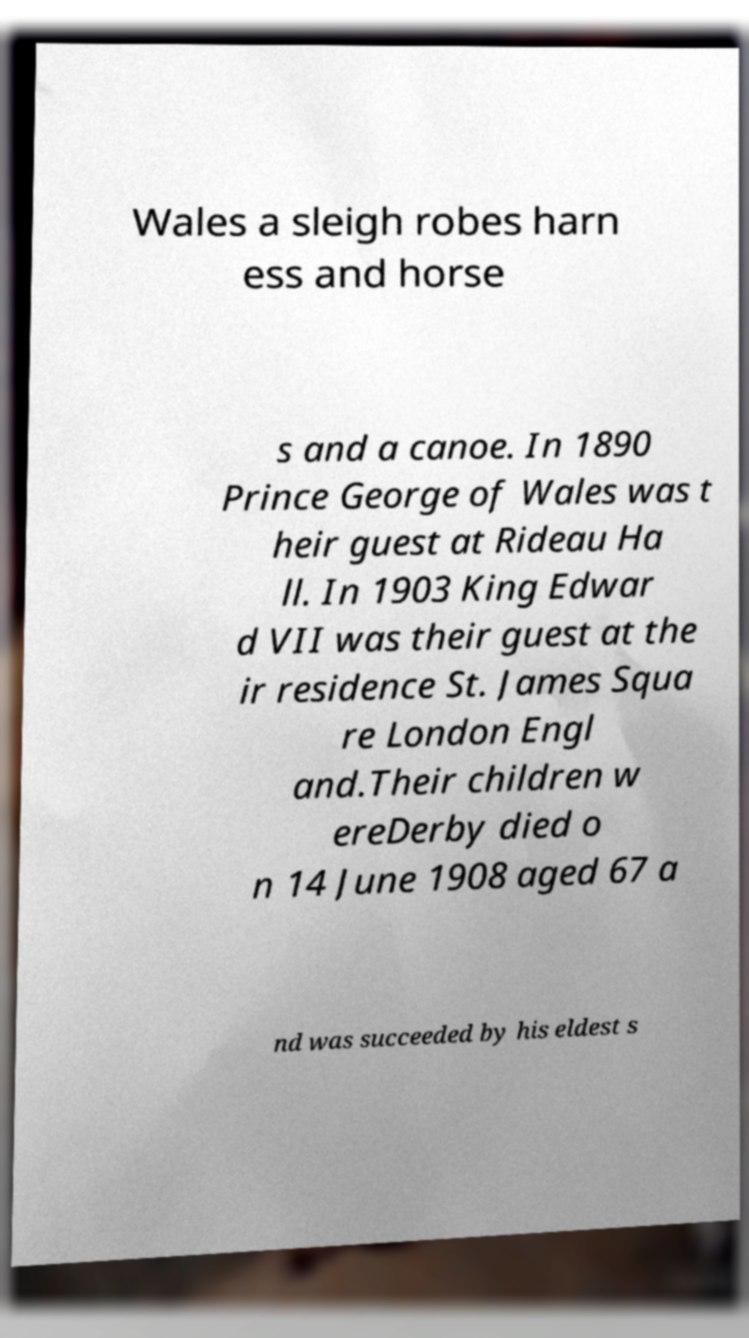What messages or text are displayed in this image? I need them in a readable, typed format. Wales a sleigh robes harn ess and horse s and a canoe. In 1890 Prince George of Wales was t heir guest at Rideau Ha ll. In 1903 King Edwar d VII was their guest at the ir residence St. James Squa re London Engl and.Their children w ereDerby died o n 14 June 1908 aged 67 a nd was succeeded by his eldest s 